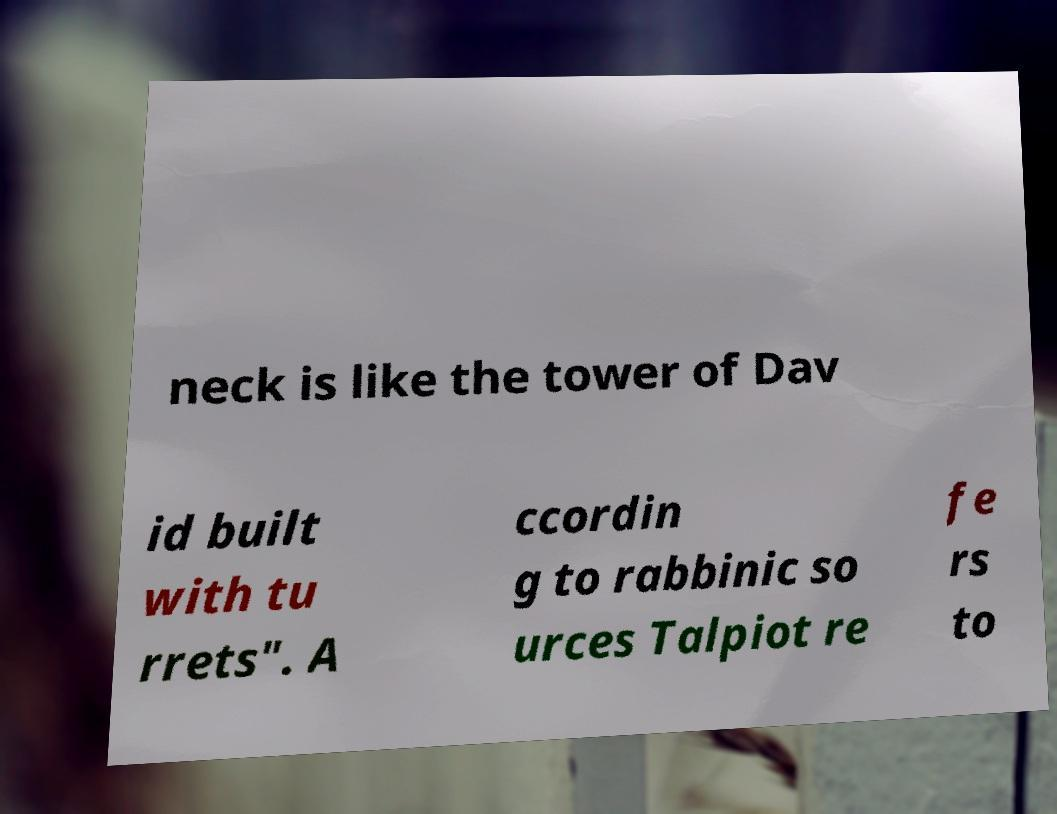Could you assist in decoding the text presented in this image and type it out clearly? neck is like the tower of Dav id built with tu rrets". A ccordin g to rabbinic so urces Talpiot re fe rs to 